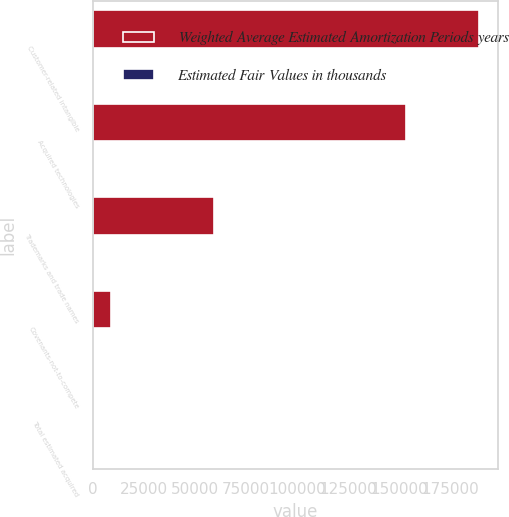Convert chart. <chart><loc_0><loc_0><loc_500><loc_500><stacked_bar_chart><ecel><fcel>Customer-related intangible<fcel>Acquired technologies<fcel>Trademarks and trade names<fcel>Covenants-not-to-compete<fcel>Total estimated acquired<nl><fcel>Weighted Average Estimated Amortization Periods years<fcel>189000<fcel>153300<fcel>59400<fcel>8845<fcel>17<nl><fcel>Estimated Fair Values in thousands<fcel>17<fcel>9<fcel>15<fcel>3<fcel>13<nl></chart> 